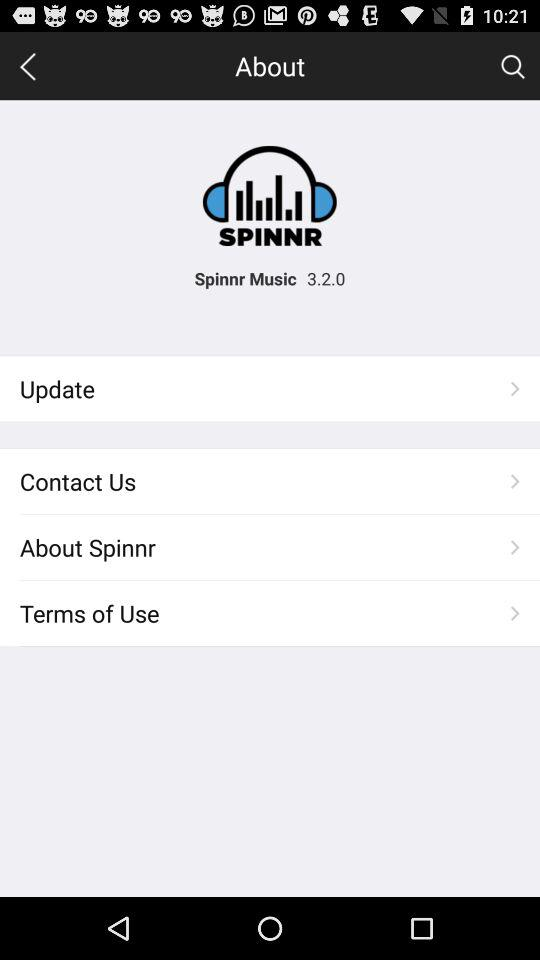What is the version number? The version number is 3.2.0. 